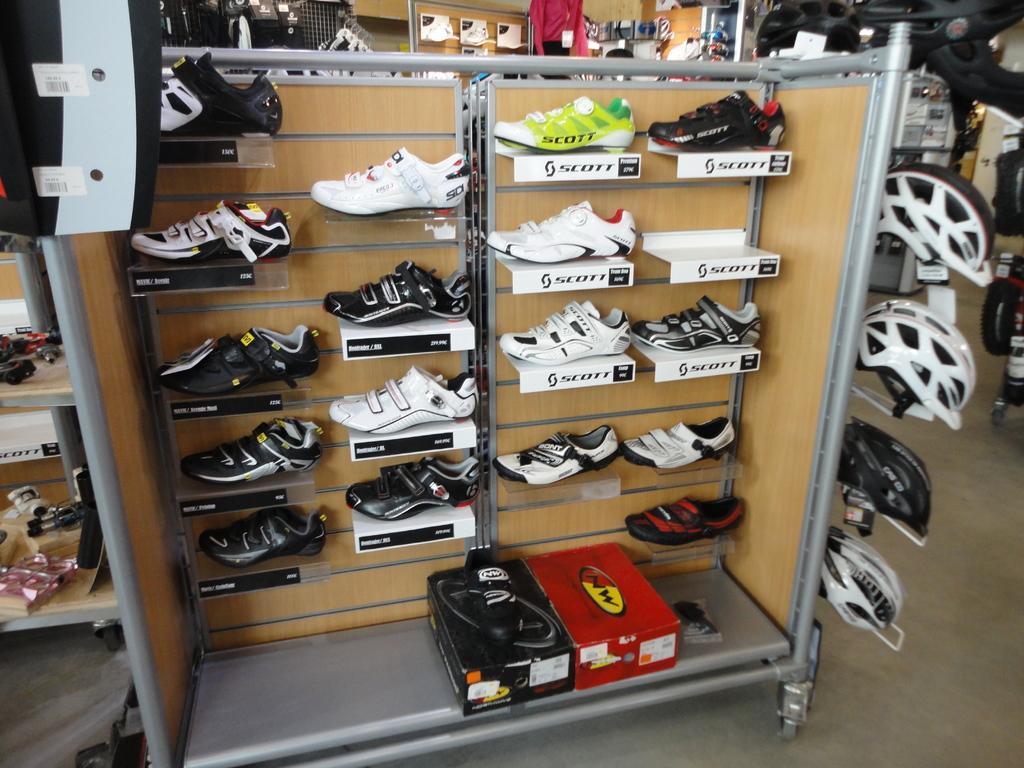Could you give a brief overview of what you see in this image? In this picture I can see the racks in front, on which there are number of shoes and I see few boards on which there is something written and on the bottom of this picture I can see 2 boxes. On the right side of this picture I can see the helmets. In the background I can see few more things. 